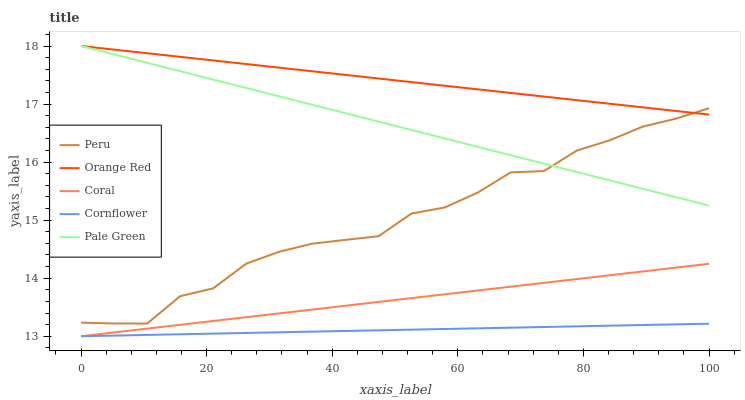Does Coral have the minimum area under the curve?
Answer yes or no. No. Does Coral have the maximum area under the curve?
Answer yes or no. No. Is Pale Green the smoothest?
Answer yes or no. No. Is Pale Green the roughest?
Answer yes or no. No. Does Pale Green have the lowest value?
Answer yes or no. No. Does Coral have the highest value?
Answer yes or no. No. Is Cornflower less than Peru?
Answer yes or no. Yes. Is Orange Red greater than Cornflower?
Answer yes or no. Yes. Does Cornflower intersect Peru?
Answer yes or no. No. 